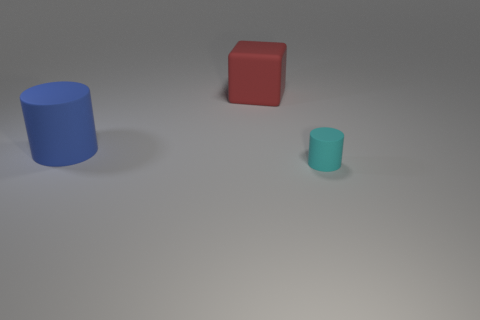Add 2 brown matte objects. How many objects exist? 5 Subtract all cubes. How many objects are left? 2 Subtract 0 red spheres. How many objects are left? 3 Subtract all cubes. Subtract all red matte blocks. How many objects are left? 1 Add 1 cylinders. How many cylinders are left? 3 Add 3 small cyan things. How many small cyan things exist? 4 